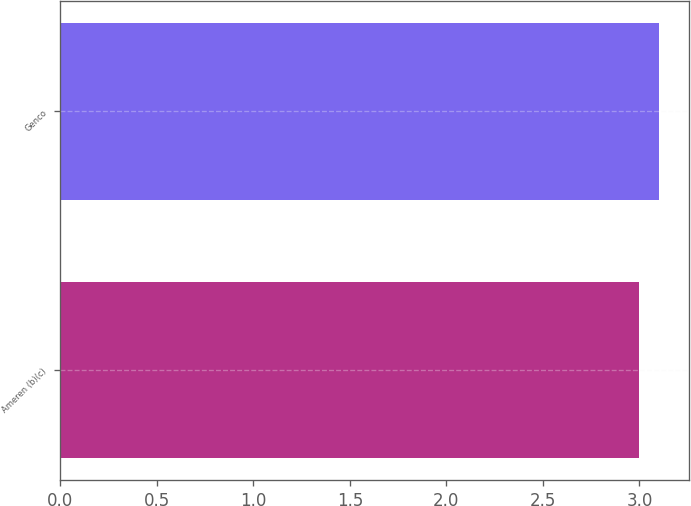<chart> <loc_0><loc_0><loc_500><loc_500><bar_chart><fcel>Ameren (b)(c)<fcel>Genco<nl><fcel>3<fcel>3.1<nl></chart> 